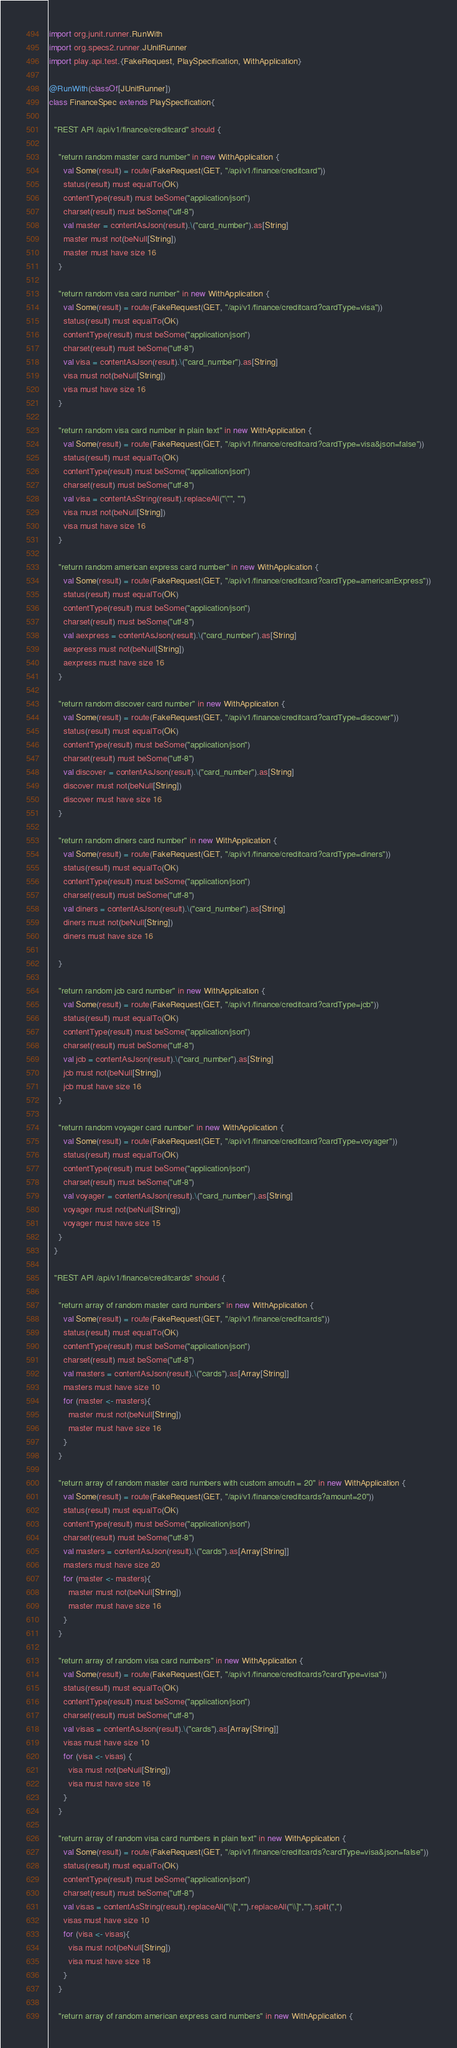Convert code to text. <code><loc_0><loc_0><loc_500><loc_500><_Scala_>import org.junit.runner.RunWith
import org.specs2.runner.JUnitRunner
import play.api.test.{FakeRequest, PlaySpecification, WithApplication}

@RunWith(classOf[JUnitRunner])
class FinanceSpec extends PlaySpecification{

  "REST API /api/v1/finance/creditcard" should {

    "return random master card number" in new WithApplication {
      val Some(result) = route(FakeRequest(GET, "/api/v1/finance/creditcard"))
      status(result) must equalTo(OK)
      contentType(result) must beSome("application/json")
      charset(result) must beSome("utf-8")
      val master = contentAsJson(result).\("card_number").as[String]
      master must not(beNull[String])
      master must have size 16
    }

    "return random visa card number" in new WithApplication {
      val Some(result) = route(FakeRequest(GET, "/api/v1/finance/creditcard?cardType=visa"))
      status(result) must equalTo(OK)
      contentType(result) must beSome("application/json")
      charset(result) must beSome("utf-8")
      val visa = contentAsJson(result).\("card_number").as[String]
      visa must not(beNull[String])
      visa must have size 16
    }

    "return random visa card number in plain text" in new WithApplication {
      val Some(result) = route(FakeRequest(GET, "/api/v1/finance/creditcard?cardType=visa&json=false"))
      status(result) must equalTo(OK)
      contentType(result) must beSome("application/json")
      charset(result) must beSome("utf-8")
      val visa = contentAsString(result).replaceAll("\"", "")
      visa must not(beNull[String])
      visa must have size 16
    }

    "return random american express card number" in new WithApplication {
      val Some(result) = route(FakeRequest(GET, "/api/v1/finance/creditcard?cardType=americanExpress"))
      status(result) must equalTo(OK)
      contentType(result) must beSome("application/json")
      charset(result) must beSome("utf-8")
      val aexpress = contentAsJson(result).\("card_number").as[String]
      aexpress must not(beNull[String])
      aexpress must have size 16
    }

    "return random discover card number" in new WithApplication {
      val Some(result) = route(FakeRequest(GET, "/api/v1/finance/creditcard?cardType=discover"))
      status(result) must equalTo(OK)
      contentType(result) must beSome("application/json")
      charset(result) must beSome("utf-8")
      val discover = contentAsJson(result).\("card_number").as[String]
      discover must not(beNull[String])
      discover must have size 16
    }

    "return random diners card number" in new WithApplication {
      val Some(result) = route(FakeRequest(GET, "/api/v1/finance/creditcard?cardType=diners"))
      status(result) must equalTo(OK)
      contentType(result) must beSome("application/json")
      charset(result) must beSome("utf-8")
      val diners = contentAsJson(result).\("card_number").as[String]
      diners must not(beNull[String])
      diners must have size 16

    }

    "return random jcb card number" in new WithApplication {
      val Some(result) = route(FakeRequest(GET, "/api/v1/finance/creditcard?cardType=jcb"))
      status(result) must equalTo(OK)
      contentType(result) must beSome("application/json")
      charset(result) must beSome("utf-8")
      val jcb = contentAsJson(result).\("card_number").as[String]
      jcb must not(beNull[String])
      jcb must have size 16
    }

    "return random voyager card number" in new WithApplication {
      val Some(result) = route(FakeRequest(GET, "/api/v1/finance/creditcard?cardType=voyager"))
      status(result) must equalTo(OK)
      contentType(result) must beSome("application/json")
      charset(result) must beSome("utf-8")
      val voyager = contentAsJson(result).\("card_number").as[String]
      voyager must not(beNull[String])
      voyager must have size 15
    }
  }

  "REST API /api/v1/finance/creditcards" should {

    "return array of random master card numbers" in new WithApplication {
      val Some(result) = route(FakeRequest(GET, "/api/v1/finance/creditcards"))
      status(result) must equalTo(OK)
      contentType(result) must beSome("application/json")
      charset(result) must beSome("utf-8")
      val masters = contentAsJson(result).\("cards").as[Array[String]]
      masters must have size 10
      for (master <- masters){
        master must not(beNull[String])
        master must have size 16
      }
    }

    "return array of random master card numbers with custom amoutn = 20" in new WithApplication {
      val Some(result) = route(FakeRequest(GET, "/api/v1/finance/creditcards?amount=20"))
      status(result) must equalTo(OK)
      contentType(result) must beSome("application/json")
      charset(result) must beSome("utf-8")
      val masters = contentAsJson(result).\("cards").as[Array[String]]
      masters must have size 20
      for (master <- masters){
        master must not(beNull[String])
        master must have size 16
      }
    }

    "return array of random visa card numbers" in new WithApplication {
      val Some(result) = route(FakeRequest(GET, "/api/v1/finance/creditcards?cardType=visa"))
      status(result) must equalTo(OK)
      contentType(result) must beSome("application/json")
      charset(result) must beSome("utf-8")
      val visas = contentAsJson(result).\("cards").as[Array[String]]
      visas must have size 10
      for (visa <- visas) {
        visa must not(beNull[String])
        visa must have size 16
      }
    }

    "return array of random visa card numbers in plain text" in new WithApplication {
      val Some(result) = route(FakeRequest(GET, "/api/v1/finance/creditcards?cardType=visa&json=false"))
      status(result) must equalTo(OK)
      contentType(result) must beSome("application/json")
      charset(result) must beSome("utf-8")
      val visas = contentAsString(result).replaceAll("\\[","").replaceAll("\\]","").split(",")
      visas must have size 10
      for (visa <- visas){
        visa must not(beNull[String])
        visa must have size 18
      }
    }

    "return array of random american express card numbers" in new WithApplication {</code> 